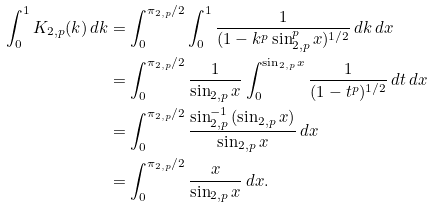Convert formula to latex. <formula><loc_0><loc_0><loc_500><loc_500>\int _ { 0 } ^ { 1 } K _ { 2 , p } ( k ) \, d k & = \int _ { 0 } ^ { \pi _ { 2 , p } / 2 } \int _ { 0 } ^ { 1 } \frac { 1 } { ( 1 - k ^ { p } \sin _ { 2 , p } ^ { p } { x } ) ^ { 1 / 2 } } \, d k \, d x \\ & = \int _ { 0 } ^ { \pi _ { 2 , p } / 2 } \frac { 1 } { \sin _ { 2 , p } { x } } \int _ { 0 } ^ { \sin _ { 2 , p } { x } } \frac { 1 } { ( 1 - t ^ { p } ) ^ { 1 / 2 } } \, d t \, d x \\ & = \int _ { 0 } ^ { \pi _ { 2 , p } / 2 } \frac { \sin _ { 2 , p } ^ { - 1 } { ( \sin _ { 2 , p } { x } ) } } { \sin _ { 2 , p } { x } } \, d x \\ & = \int _ { 0 } ^ { \pi _ { 2 , p } / 2 } \frac { x } { \sin _ { 2 , p } { x } } \, d x .</formula> 